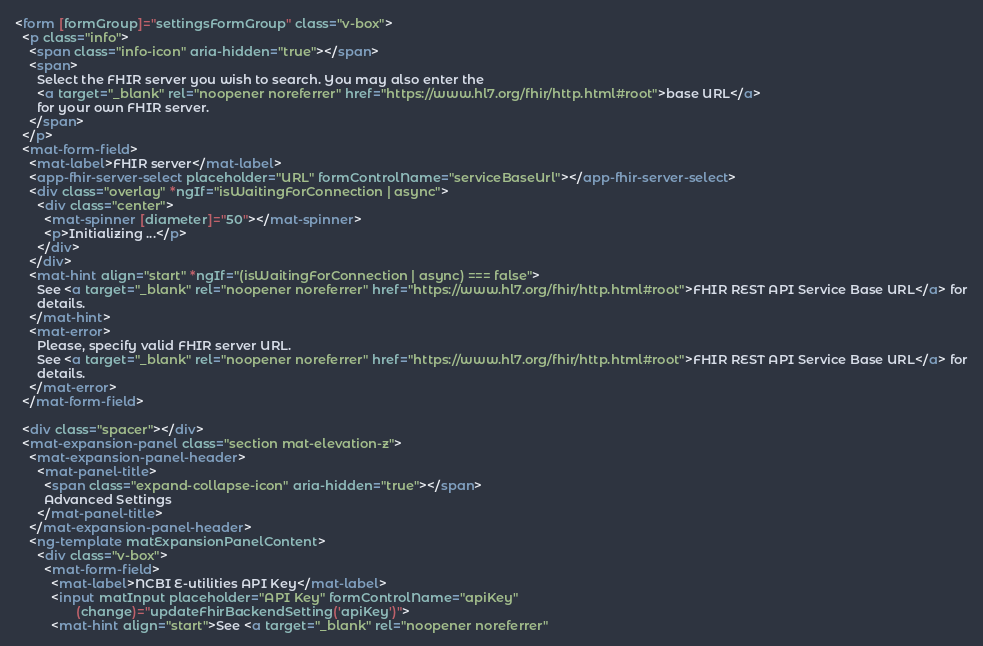Convert code to text. <code><loc_0><loc_0><loc_500><loc_500><_HTML_><form [formGroup]="settingsFormGroup" class="v-box">
  <p class="info">
    <span class="info-icon" aria-hidden="true"></span>
    <span>
      Select the FHIR server you wish to search. You may also enter the
      <a target="_blank" rel="noopener noreferrer" href="https://www.hl7.org/fhir/http.html#root">base URL</a>
      for your own FHIR server.
    </span>
  </p>
  <mat-form-field>
    <mat-label>FHIR server</mat-label>
    <app-fhir-server-select placeholder="URL" formControlName="serviceBaseUrl"></app-fhir-server-select>
    <div class="overlay" *ngIf="isWaitingForConnection | async">
      <div class="center">
        <mat-spinner [diameter]="50"></mat-spinner>
        <p>Initializing ...</p>
      </div>
    </div>
    <mat-hint align="start" *ngIf="(isWaitingForConnection | async) === false">
      See <a target="_blank" rel="noopener noreferrer" href="https://www.hl7.org/fhir/http.html#root">FHIR REST API Service Base URL</a> for
      details.
    </mat-hint>
    <mat-error>
      Please, specify valid FHIR server URL.
      See <a target="_blank" rel="noopener noreferrer" href="https://www.hl7.org/fhir/http.html#root">FHIR REST API Service Base URL</a> for
      details.
    </mat-error>
  </mat-form-field>

  <div class="spacer"></div>
  <mat-expansion-panel class="section mat-elevation-z">
    <mat-expansion-panel-header>
      <mat-panel-title>
        <span class="expand-collapse-icon" aria-hidden="true"></span>
        Advanced Settings
      </mat-panel-title>
    </mat-expansion-panel-header>
    <ng-template matExpansionPanelContent>
      <div class="v-box">
        <mat-form-field>
          <mat-label>NCBI E-utilities API Key</mat-label>
          <input matInput placeholder="API Key" formControlName="apiKey"
                 (change)="updateFhirBackendSetting('apiKey')">
          <mat-hint align="start">See <a target="_blank" rel="noopener noreferrer"</code> 